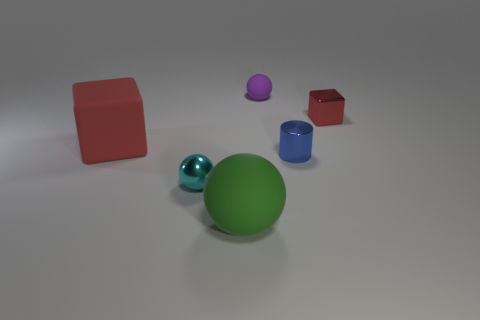Add 3 tiny gray rubber cylinders. How many objects exist? 9 Subtract all cylinders. How many objects are left? 5 Subtract 0 green cylinders. How many objects are left? 6 Subtract all big cyan shiny blocks. Subtract all cylinders. How many objects are left? 5 Add 4 big rubber spheres. How many big rubber spheres are left? 5 Add 4 blue blocks. How many blue blocks exist? 4 